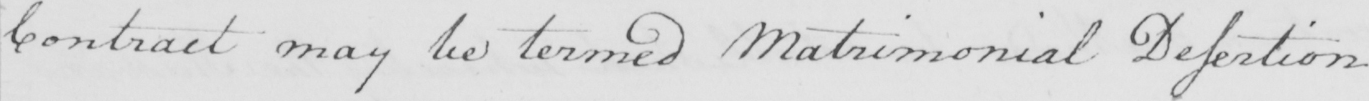What does this handwritten line say? contract may be termed Matrimonial Dessertion . 